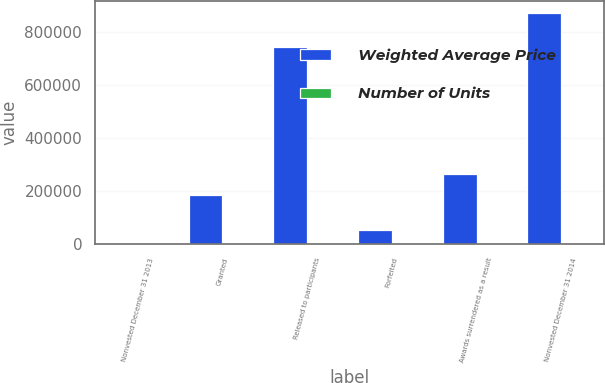Convert chart to OTSL. <chart><loc_0><loc_0><loc_500><loc_500><stacked_bar_chart><ecel><fcel>Nonvested December 31 2013<fcel>Granted<fcel>Released to participants<fcel>Forfeited<fcel>Awards surrendered as a result<fcel>Nonvested December 31 2014<nl><fcel>Weighted Average Price<fcel>64.75<fcel>186436<fcel>743897<fcel>53927<fcel>265750<fcel>872730<nl><fcel>Number of Units<fcel>41.1<fcel>64.75<fcel>34.68<fcel>48.99<fcel>47.62<fcel>44.55<nl></chart> 